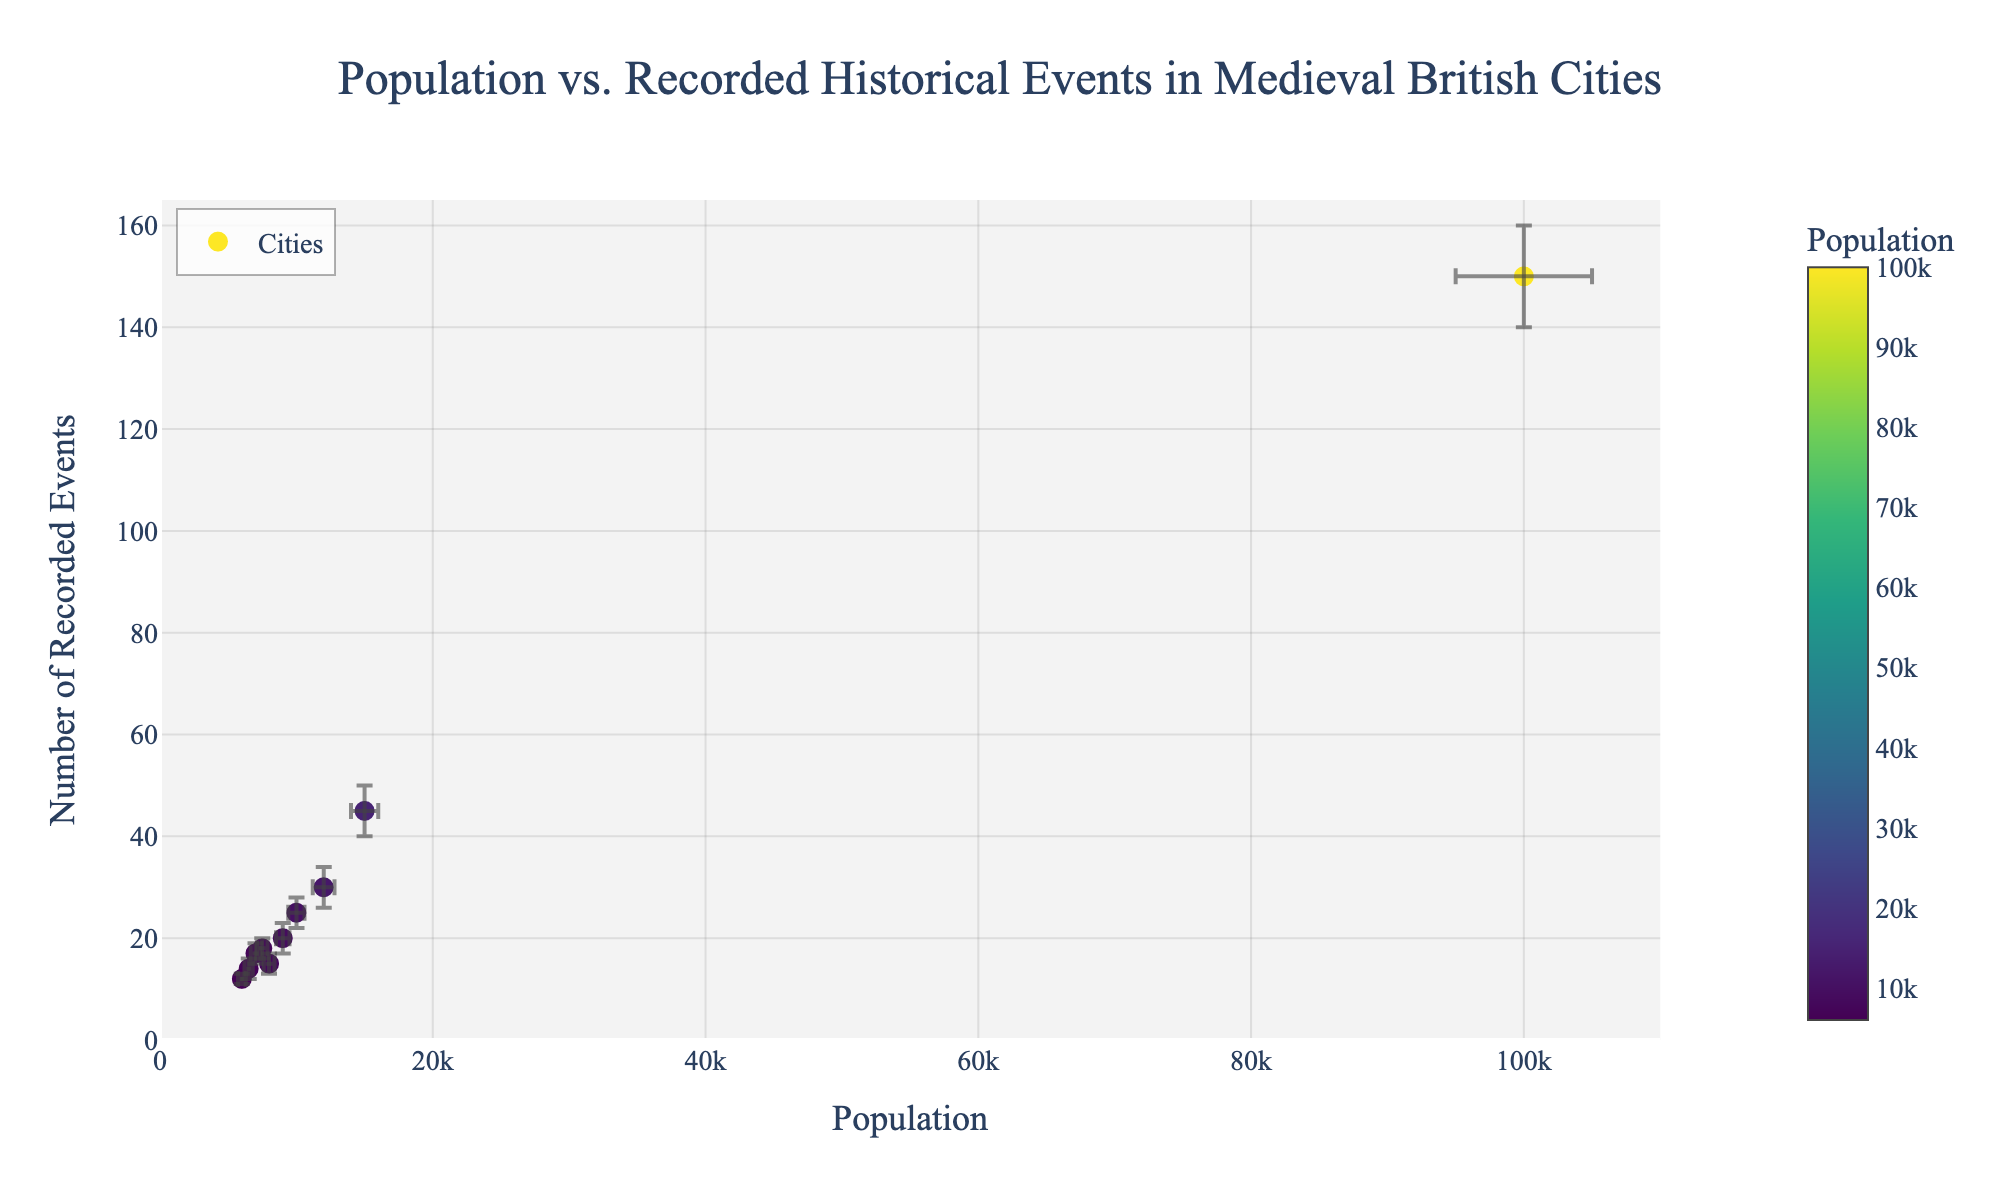What is the title of the figure? The title is usually located at the top of the figure and provides a summary of what the figure represents. In this case, the title is clearly stated and easy to identify.
Answer: Population vs. Recorded Historical Events in Medieval British Cities How many cities are represented in the figure? Count the number of distinct data points (markers) on the scatter plot. Each marker represents a city. There are 10 distinct data points.
Answer: 10 Which city has the highest population depicted in the figure? The city with the marker farthest to the right on the x-axis (horizontal axis) represents the city with the highest population. In this case, it is London.
Answer: London What is the recorded number of historical events for York, and what are its error margins? Locate the marker for York by checking the hover information. York has 45 recorded events, with an error margin of ±5.
Answer: 45 events, ±5 Which city has the smallest population but more than 20 recorded historical events? Look for the smallest x-axis value (population) where the y-axis value (recorded events) is greater than 20. Salisbury, with 12 events and a population of 6000.
Answer: Salisbury What is the range of error values for the population sizes across all cities? Error ranges of population sizes can be determined by checking the smallest and largest error values for the population across all data points. The smallest error is 280, and the largest is 5000.
Answer: 280 to 5000 Do larger cities tend to have more recorded historical events? Review the trend in the scatter plot by observing if higher x-axis values (population) correspond to higher y-axis values (recorded events). Larger cities like London with higher populations do tend to have more recorded events.
Answer: Yes Which city has the highest number of recorded events and what is its error margin? Find the marker that is highest on the y-axis. London has the highest number of recorded events, 150, with an error margin of ±10.
Answer: London, ±10 How does the number of recorded events in Canterbury compare to that in Oxford? Find the markers for Canterbury and Oxford, and compare their y-axis values for recorded events. Canterbury has 18 recorded events, and Oxford has 17.
Answer: Canterbury has 1 more event Considering error bars, which city has the greatest range of uncertainties in its recorded events? Look at the error bars and find the city with the largest vertical error bar (y-axis). London shows the greatest uncertainty range with ±10 events.
Answer: London 